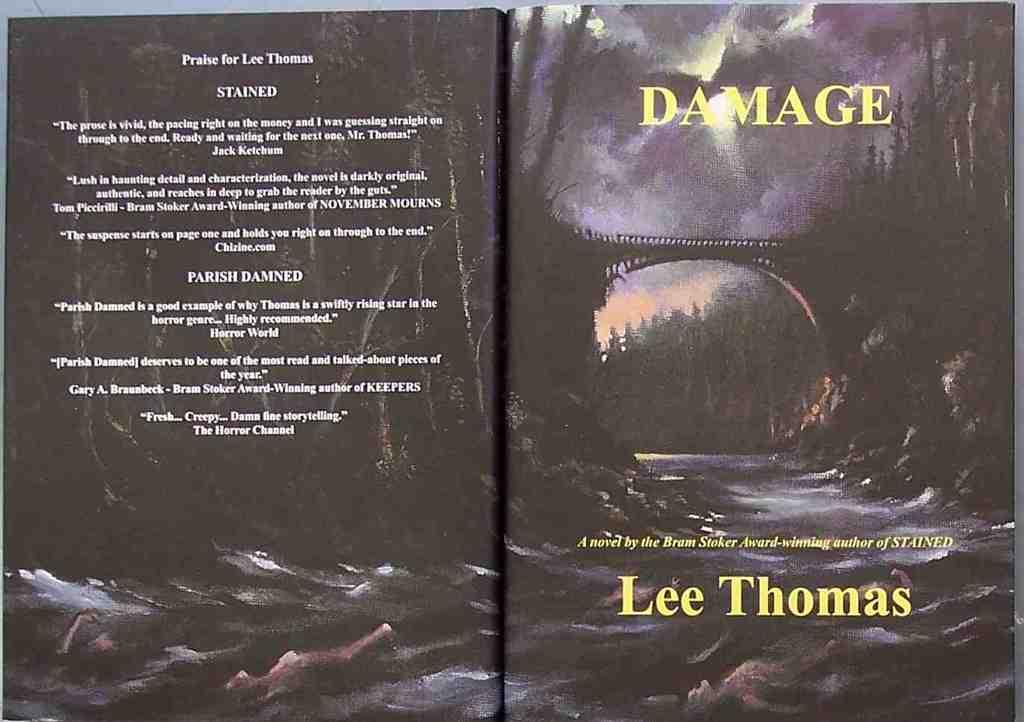What is the title?
Ensure brevity in your answer.  Damage. 